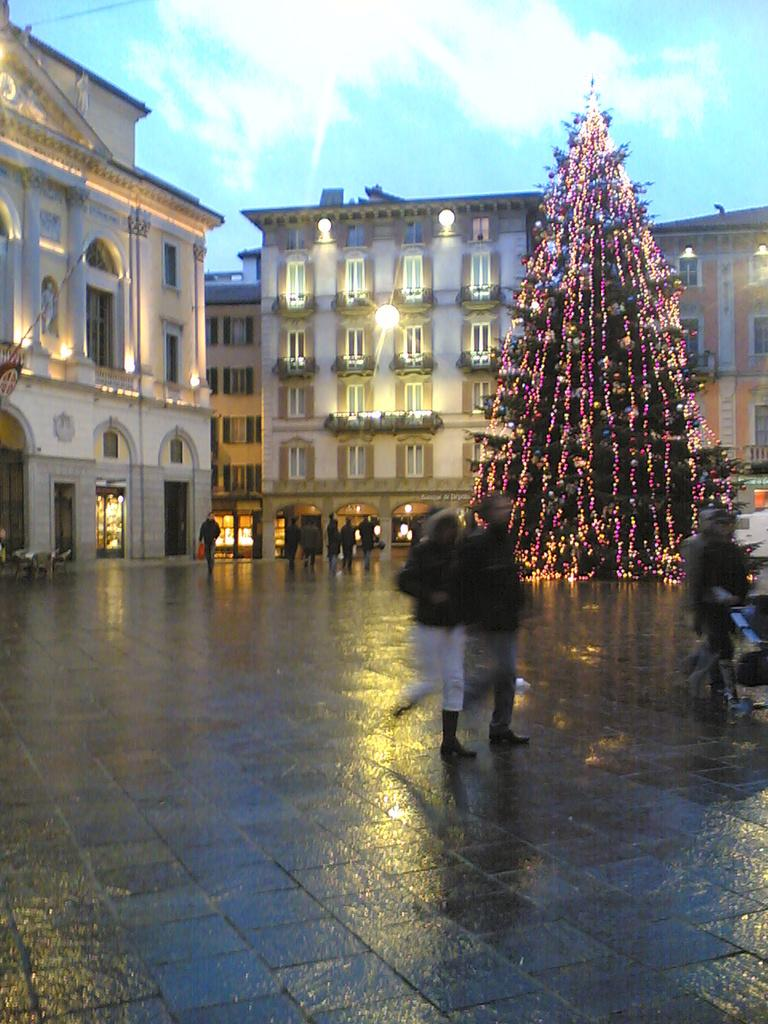What type of structures are located in the middle of the image? There are buildings in the middle of the image. What seasonal decoration can be seen on the right side of the image? There is a Christmas tree on the right side of the image. Who or what is present in the middle of the image? There are people in the middle of the image. What is visible at the top of the image? The sky is visible at the top of the image. Can you describe the operation of the tiger in the image? There is no tiger present in the image, so it is not possible to describe its operation. What force is being applied to the buildings in the image? There is no indication of any force being applied to the buildings in the image; they appear to be stationary. 